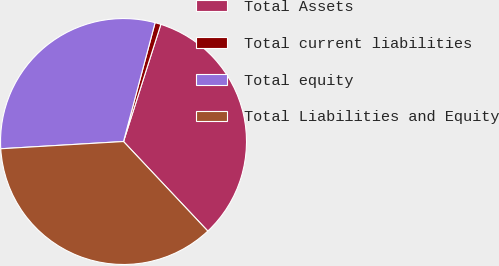<chart> <loc_0><loc_0><loc_500><loc_500><pie_chart><fcel>Total Assets<fcel>Total current liabilities<fcel>Total equity<fcel>Total Liabilities and Equity<nl><fcel>33.07%<fcel>0.78%<fcel>30.07%<fcel>36.08%<nl></chart> 